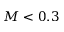Convert formula to latex. <formula><loc_0><loc_0><loc_500><loc_500>M < 0 . 3</formula> 